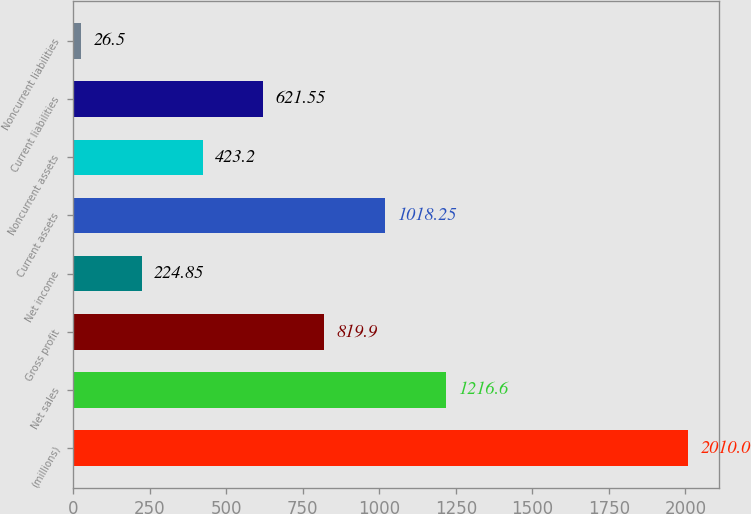Convert chart. <chart><loc_0><loc_0><loc_500><loc_500><bar_chart><fcel>(millions)<fcel>Net sales<fcel>Gross profit<fcel>Net income<fcel>Current assets<fcel>Noncurrent assets<fcel>Current liabilities<fcel>Noncurrent liabilities<nl><fcel>2010<fcel>1216.6<fcel>819.9<fcel>224.85<fcel>1018.25<fcel>423.2<fcel>621.55<fcel>26.5<nl></chart> 